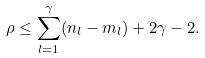<formula> <loc_0><loc_0><loc_500><loc_500>\rho \leq \sum _ { l = 1 } ^ { \gamma } ( n _ { l } - m _ { l } ) + 2 \gamma - 2 .</formula> 